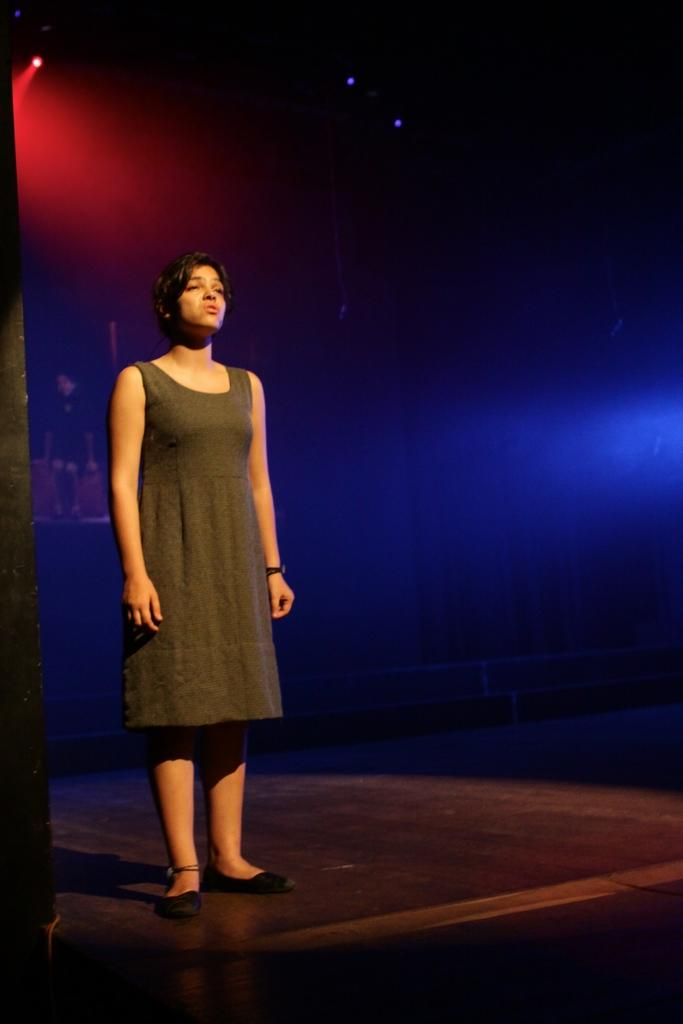Who is the main subject in the image? There is a woman in the image. What is the woman wearing? The woman is wearing a black dress. Where is the woman located in the image? The woman is standing on a stage. What is the color of the background in the image? The background of the image is dark. What type of lighting can be seen in the background? Blue and red color lights are visible in the background. What type of jelly is being served on the stage in the image? There is no jelly present in the image; the woman is standing on a stage, but no food or beverages are visible. 